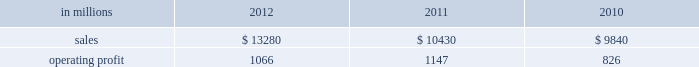( $ 125 million ) and higher maintenance outage costs ( $ 18 million ) .
Additionally , operating profits in 2012 include costs of $ 184 million associated with the acquisition and integration of temple-inland , mill divestiture costs of $ 91 million , costs associated with the restructuring of our european packaging busi- ness of $ 17 million and a $ 3 million gain for other items , while operating costs in 2011 included costs associated with signing an agreement to acquire temple-inland of $ 20 million and a gain of $ 7 million for other items .
Industrial packaging .
North american industr ia l packaging net sales were $ 11.6 billion in 2012 compared with $ 8.6 billion in 2011 and $ 8.4 billion in 2010 .
Operating profits in 2012 were $ 1.0 billion ( $ 1.3 billion exclud- ing costs associated with the acquisition and integration of temple-inland and mill divestiture costs ) compared with $ 1.1 billion ( both including and excluding costs associated with signing an agree- ment to acquire temple-inland ) in 2011 and $ 763 million ( $ 776 million excluding facility closure costs ) in 2010 .
Sales volumes for the legacy business were about flat in 2012 compared with 2011 .
Average sales price was lower mainly due to export containerboard sales prices which bottomed out in the first quarter but climbed steadily the rest of the year .
Input costs were lower for recycled fiber , wood and natural gas , but higher for starch .
Freight costs also increased .
Plan- ned maintenance downtime costs were higher than in 2011 .
Operating costs were higher largely due to routine inventory valuation adjustments operating profits in 2012 benefited from $ 235 million of temple-inland synergies .
Market-related downtime in 2012 was about 570000 tons compared with about 380000 tons in 2011 .
Operating profits in 2012 included $ 184 million of costs associated with the acquisition and integration of temple-inland and $ 91 million of costs associated with the divestiture of three containerboard mills .
Operating profits in 2011 included charges of $ 20 million for costs associated with the signing of the agreement to acquire temple- inland .
Looking ahead to 2013 , sales volumes in the first quarter compared with the fourth quarter of 2012 are expected to increase slightly for boxes due to a higher number of shipping days .
Average sales price realizations are expected to reflect the pass-through to box customers of a containerboard price increase implemented in 2012 .
Input costs are expected to be higher for recycled fiber , wood and starch .
Planned maintenance downtime costs are expected to be about $ 26 million higher with outages scheduled at eight mills compared with six mills in the 2012 fourth quarter .
Manufacturing operating costs are expected to be lower .
European industr ia l packaging net sales were $ 1.0 billion in 2012 compared with $ 1.1 billion in 2011 and $ 990 million in 2010 .
Operating profits in 2012 were $ 53 million ( $ 72 million excluding restructuring costs ) compared with $ 66 million ( $ 61 million excluding a gain for a bargain purchase price adjustment on an acquisition by our joint venture in turkey and costs associated with the closure of our etienne mill in france in 2009 ) in 2011 and $ 70 mil- lion ( $ 73 million before closure costs for our etienne mill ) in 2010 .
Sales volumes in 2012 were lower than in 2011 reflecting decreased demand for packaging in the industrial market due to a weaker overall economic environment in southern europe .
Demand for pack- aging in the agricultural markets was about flat year- over-year .
Average sales margins increased due to sales price increases implemented during 2011 and 2012 and lower board costs .
Other input costs were higher , primarily for energy and distribution .
Operat- ing profits in 2012 included a net gain of $ 10 million for an insurance settlement , partially offset by addi- tional operating costs , related to the earthquakes in northern italy in may which affected our san felice box plant .
Entering the first quarter of 2013 , sales volumes are expected to be stable reflecting a seasonal decrease in market demand in agricultural markets offset by an increase in industrial markets .
Average sales margins are expected to improve due to lower input costs for containerboard .
Other input costs should be about flat .
Operating costs are expected to be higher reflecting the absence of the earthquake insurance settlement that was received in the 2012 fourth quar- asian industr ia l packaging net sales and operating profits include the results of sca pack- aging since the acquisition on june 30 , 2010 , includ- ing the impact of incremental integration costs .
Net sales for the packaging operations were $ 400 million in 2012 compared with $ 410 million in 2011 and $ 255 million in 2010 .
Operating profits for the packaging operations were $ 2 million in 2012 compared with $ 2 million in 2011 and a loss of $ 7 million ( a loss of $ 4 million excluding facility closure costs ) in 2010 .
Operating profits were favorably impacted by higher average sales margins in 2012 compared with 2011 , but this benefit was offset by lower sales volumes and higher raw material costs and operating costs .
Looking ahead to the first quarter of 2013 , sales volumes and average sales margins are expected to decrease due to seasonality .
Net sales for the distribution operations were $ 260 million in 2012 compared with $ 285 million in 2011 and $ 240 million in 2010 .
Operating profits were $ 3 million in 2012 compared with $ 3 million in 2011 and about breakeven in 2010. .
North american industrial packaging net sales where what percent of industrial packaging sales in 2012? 
Computations: ((11.6 * 1000) / 13280)
Answer: 0.87349. 